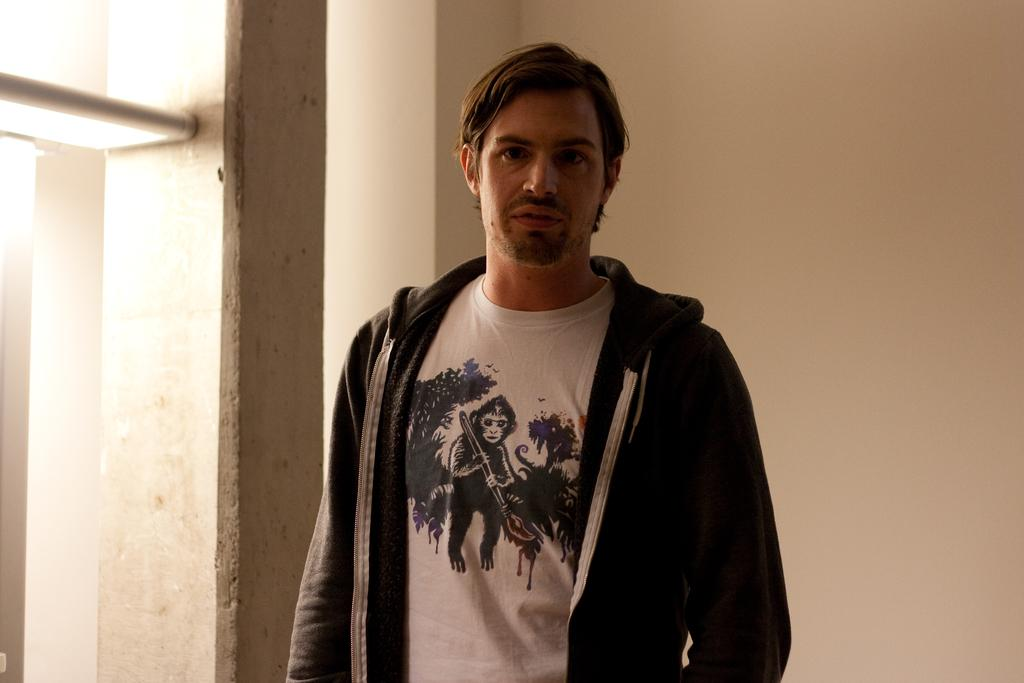Who is present in the image? There is a man in the image. What is the man doing in the image? The man is standing. What is the man wearing in the image? The man is wearing a white t-shirt and a black hoodie. What can be seen in the background of the image? There is a white wall, a pillar, and light in the background of the image. What book is the man holding in the image? There is no book present in the image. What type of lumber is visible in the image? There is no lumber visible in the image. 